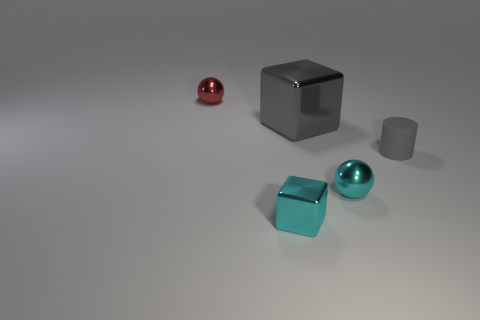Add 3 tiny cyan cubes. How many objects exist? 8 Subtract all balls. How many objects are left? 3 Subtract all yellow matte cylinders. Subtract all balls. How many objects are left? 3 Add 4 tiny red objects. How many tiny red objects are left? 5 Add 5 large brown matte cylinders. How many large brown matte cylinders exist? 5 Subtract 0 brown balls. How many objects are left? 5 